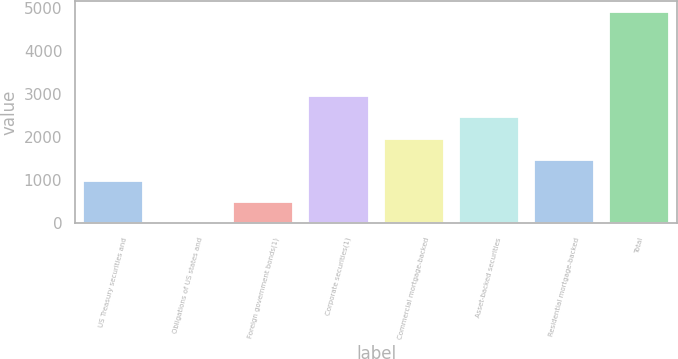Convert chart. <chart><loc_0><loc_0><loc_500><loc_500><bar_chart><fcel>US Treasury securities and<fcel>Obligations of US states and<fcel>Foreign government bonds(1)<fcel>Corporate securities(1)<fcel>Commercial mortgage-backed<fcel>Asset-backed securities<fcel>Residential mortgage-backed<fcel>Total<nl><fcel>983.46<fcel>2.32<fcel>492.89<fcel>2945.74<fcel>1964.6<fcel>2455.17<fcel>1474.03<fcel>4908<nl></chart> 